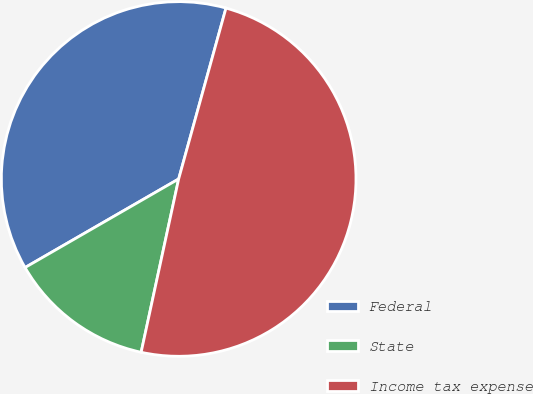<chart> <loc_0><loc_0><loc_500><loc_500><pie_chart><fcel>Federal<fcel>State<fcel>Income tax expense<nl><fcel>37.62%<fcel>13.28%<fcel>49.09%<nl></chart> 